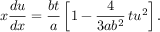<formula> <loc_0><loc_0><loc_500><loc_500>x \frac { d u } { d x } = \frac { b t } { a } \left [ 1 - \frac { 4 } { 3 a b ^ { 2 } } \, t u ^ { 2 } \right ] .</formula> 